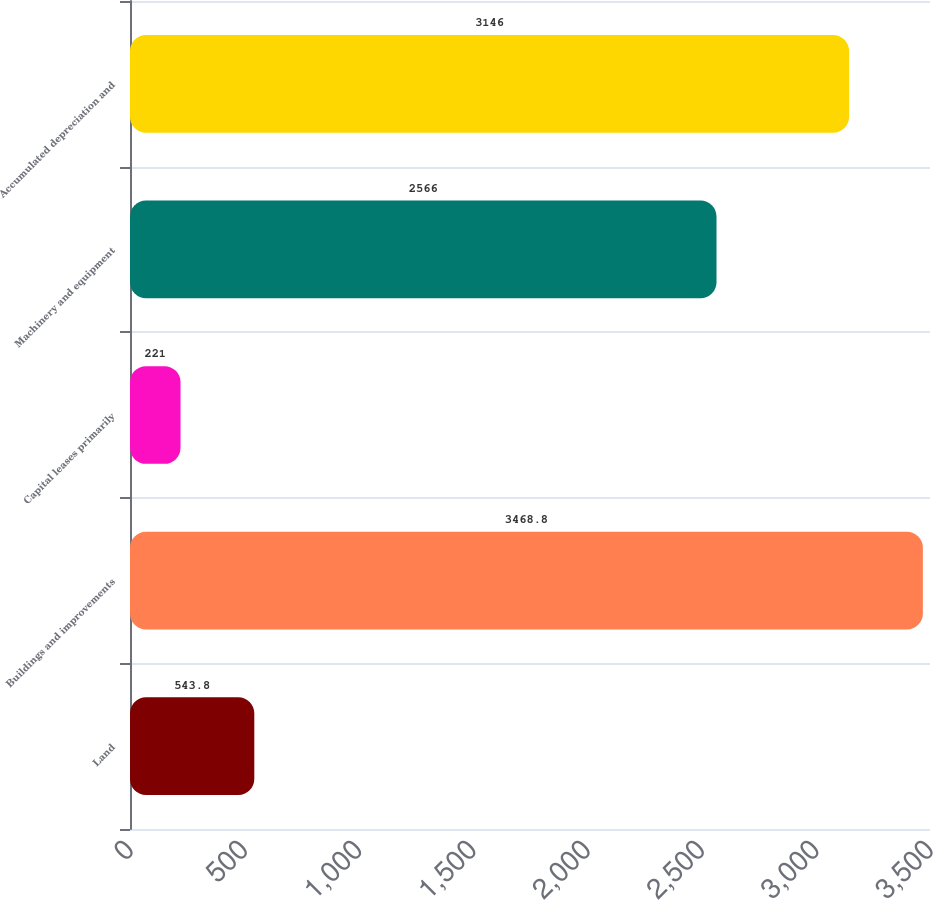Convert chart to OTSL. <chart><loc_0><loc_0><loc_500><loc_500><bar_chart><fcel>Land<fcel>Buildings and improvements<fcel>Capital leases primarily<fcel>Machinery and equipment<fcel>Accumulated depreciation and<nl><fcel>543.8<fcel>3468.8<fcel>221<fcel>2566<fcel>3146<nl></chart> 